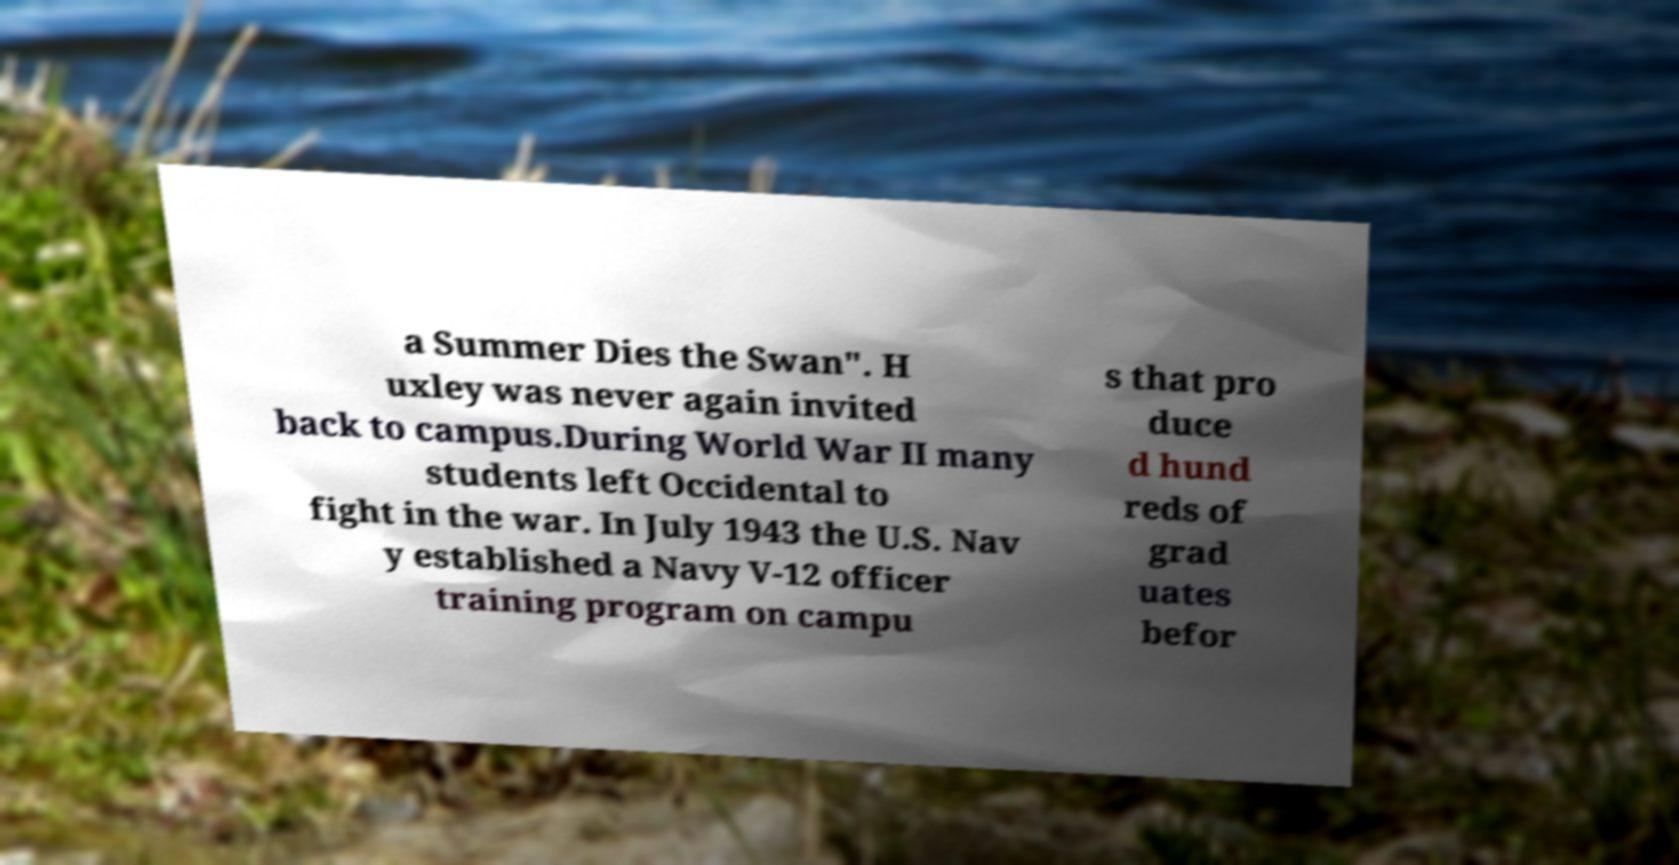I need the written content from this picture converted into text. Can you do that? a Summer Dies the Swan". H uxley was never again invited back to campus.During World War II many students left Occidental to fight in the war. In July 1943 the U.S. Nav y established a Navy V-12 officer training program on campu s that pro duce d hund reds of grad uates befor 